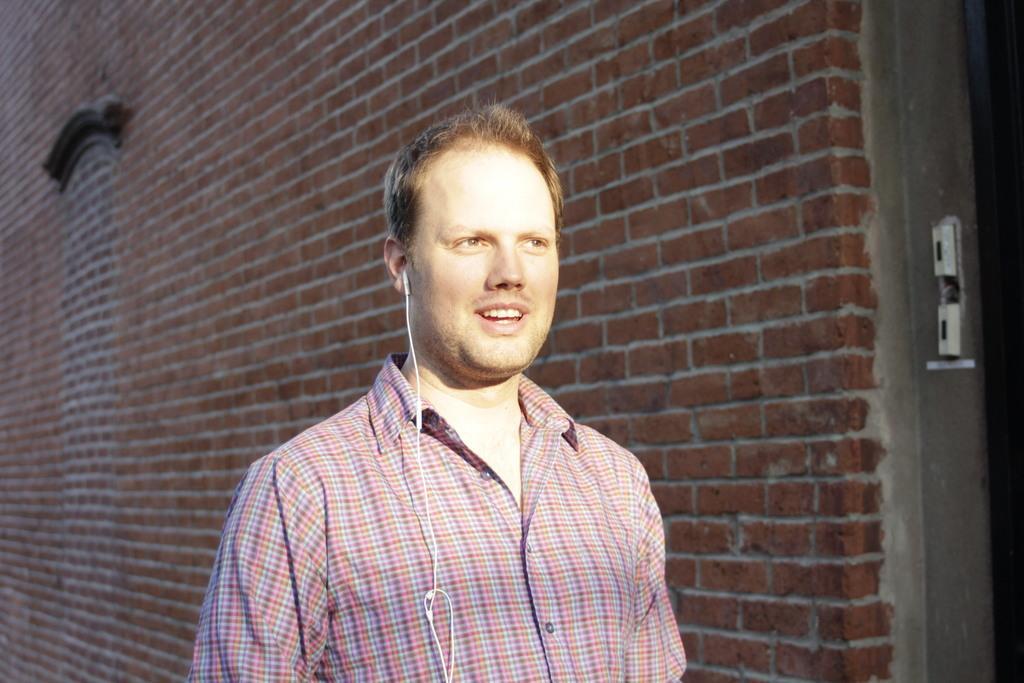Describe this image in one or two sentences. As we can see in the image there is a building, earphones and a person standing over here. 